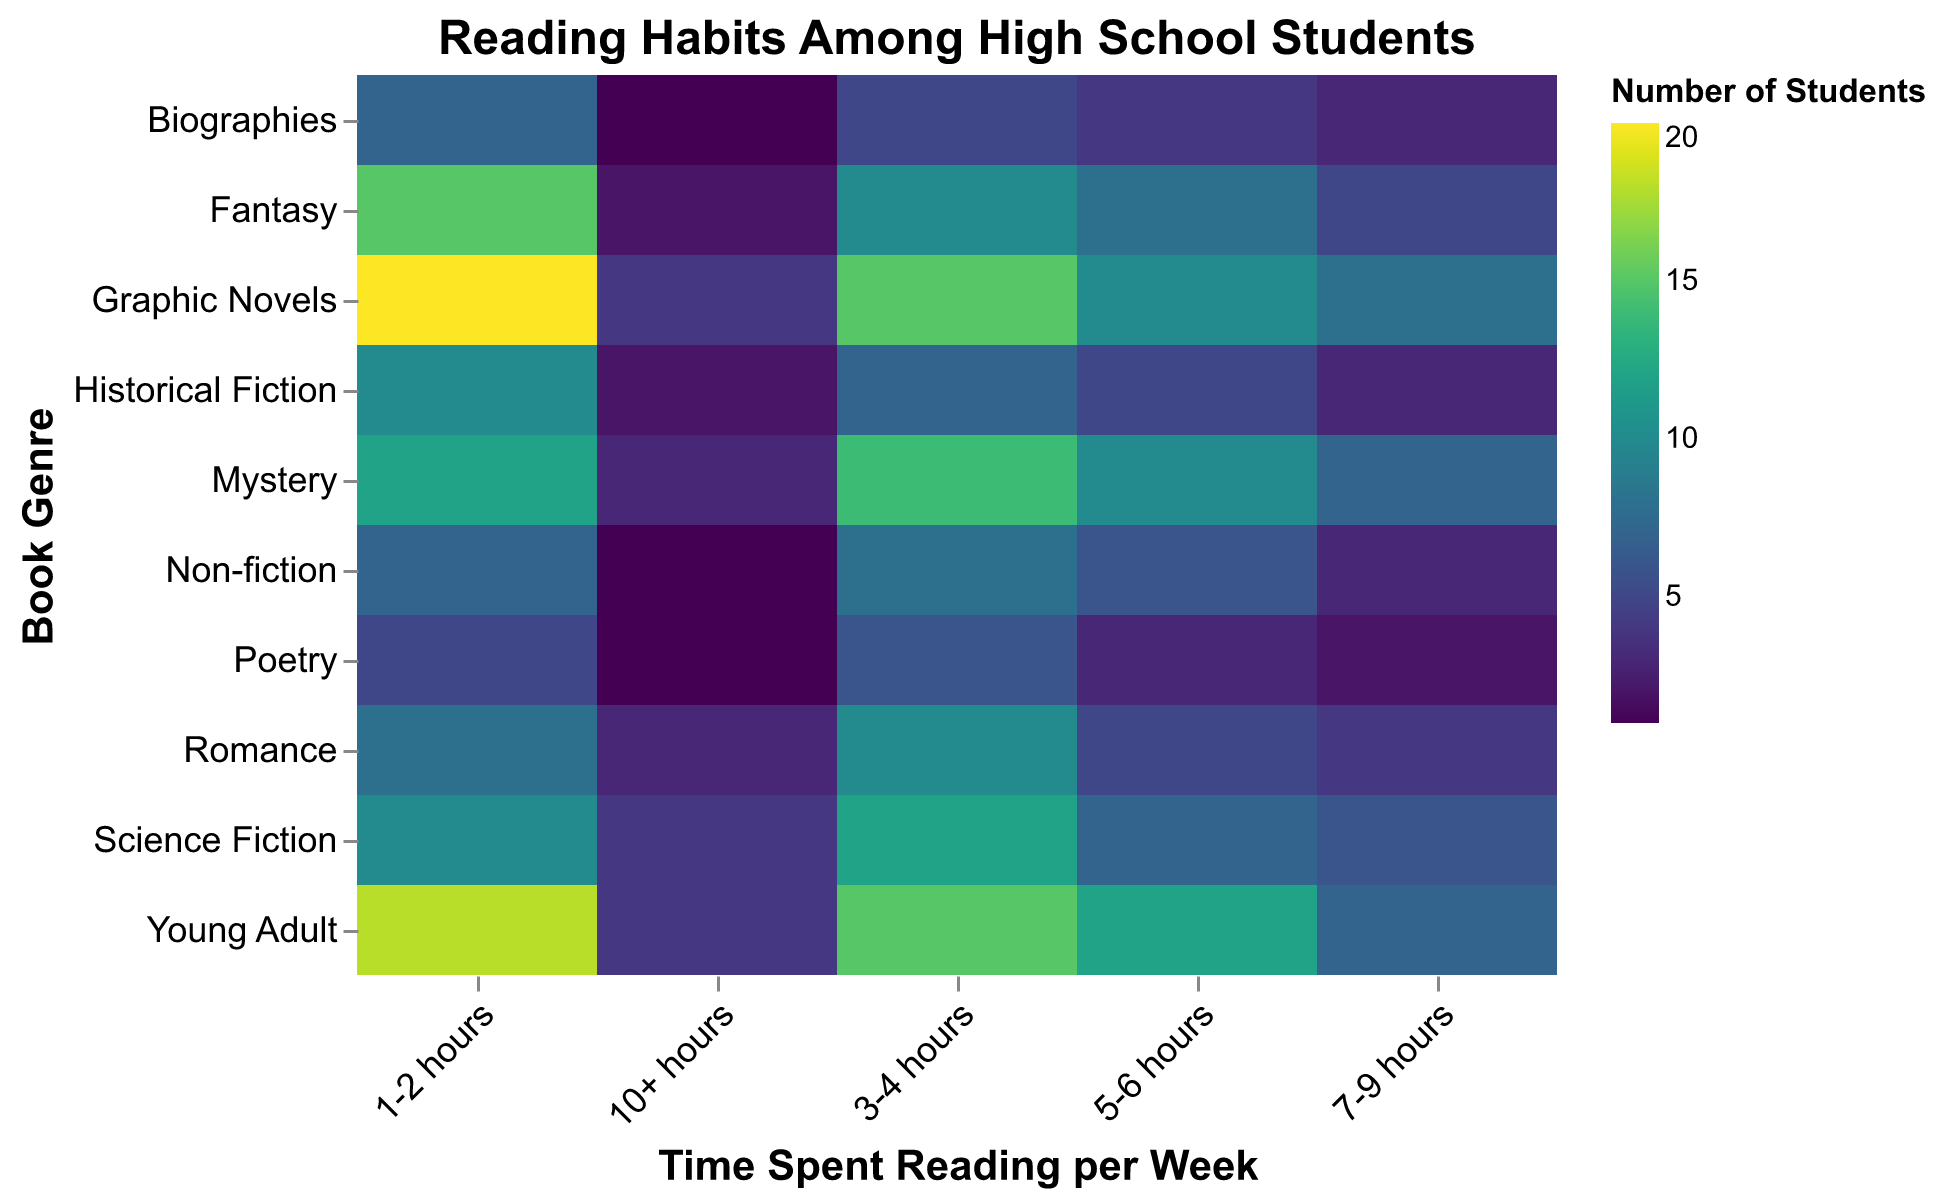What is the title of the heatmap? The title is located at the top of the heatmap in bold and larger font. It provides a quick overview of the heatmap content.
Answer: Reading Habits Among High School Students Which book genre has the highest number of students reading 1-2 hours per week? Look at the column corresponding to "1-2 hours" and find the cell with the highest value.
Answer: Graphic Novels How many students read Romance books for 5-6 hours per week? Find the cell where the "Romance" row intersects with the "5-6 hours" column.
Answer: 5 Which genre has the fewest number of students reading for 10+ hours per week? Check the values in the "10+ hours" column and identify the smallest number.
Answer: Non-fiction and Poetry (both 1) What is the total number of students who read Fantasy books for up to 4 hours per week? Sum the values for Fantasy in the "1-2 hours" and "3-4 hours" columns.
Answer: 25 Compare the number of students reading Graphic Novels and Young Adult books for 3-4 hours per week. Which genre has more readers? Look at the "3-4 hours" column and compare the values for Graphic Novels and Young Adult.
Answer: Graphic Novels Which genre has more students reading 7-9 hours per week: Science Fiction or Mystery? Check the "7-9 hours" column and compare the values for Science Fiction and Mystery.
Answer: Mystery What is the average number of students reading Mystery books for more than 6 hours per week? Sum the values for Mystery in the "7-9 hours" and "10+ hours" columns and divide by 2.
Answer: 5 Calculate the difference in the number of students reading Historical Fiction and Romance for 1-2 hours per week. Subtract the value for Romance in the "1-2 hours" column from the value for Historical Fiction in the same column.
Answer: 2 